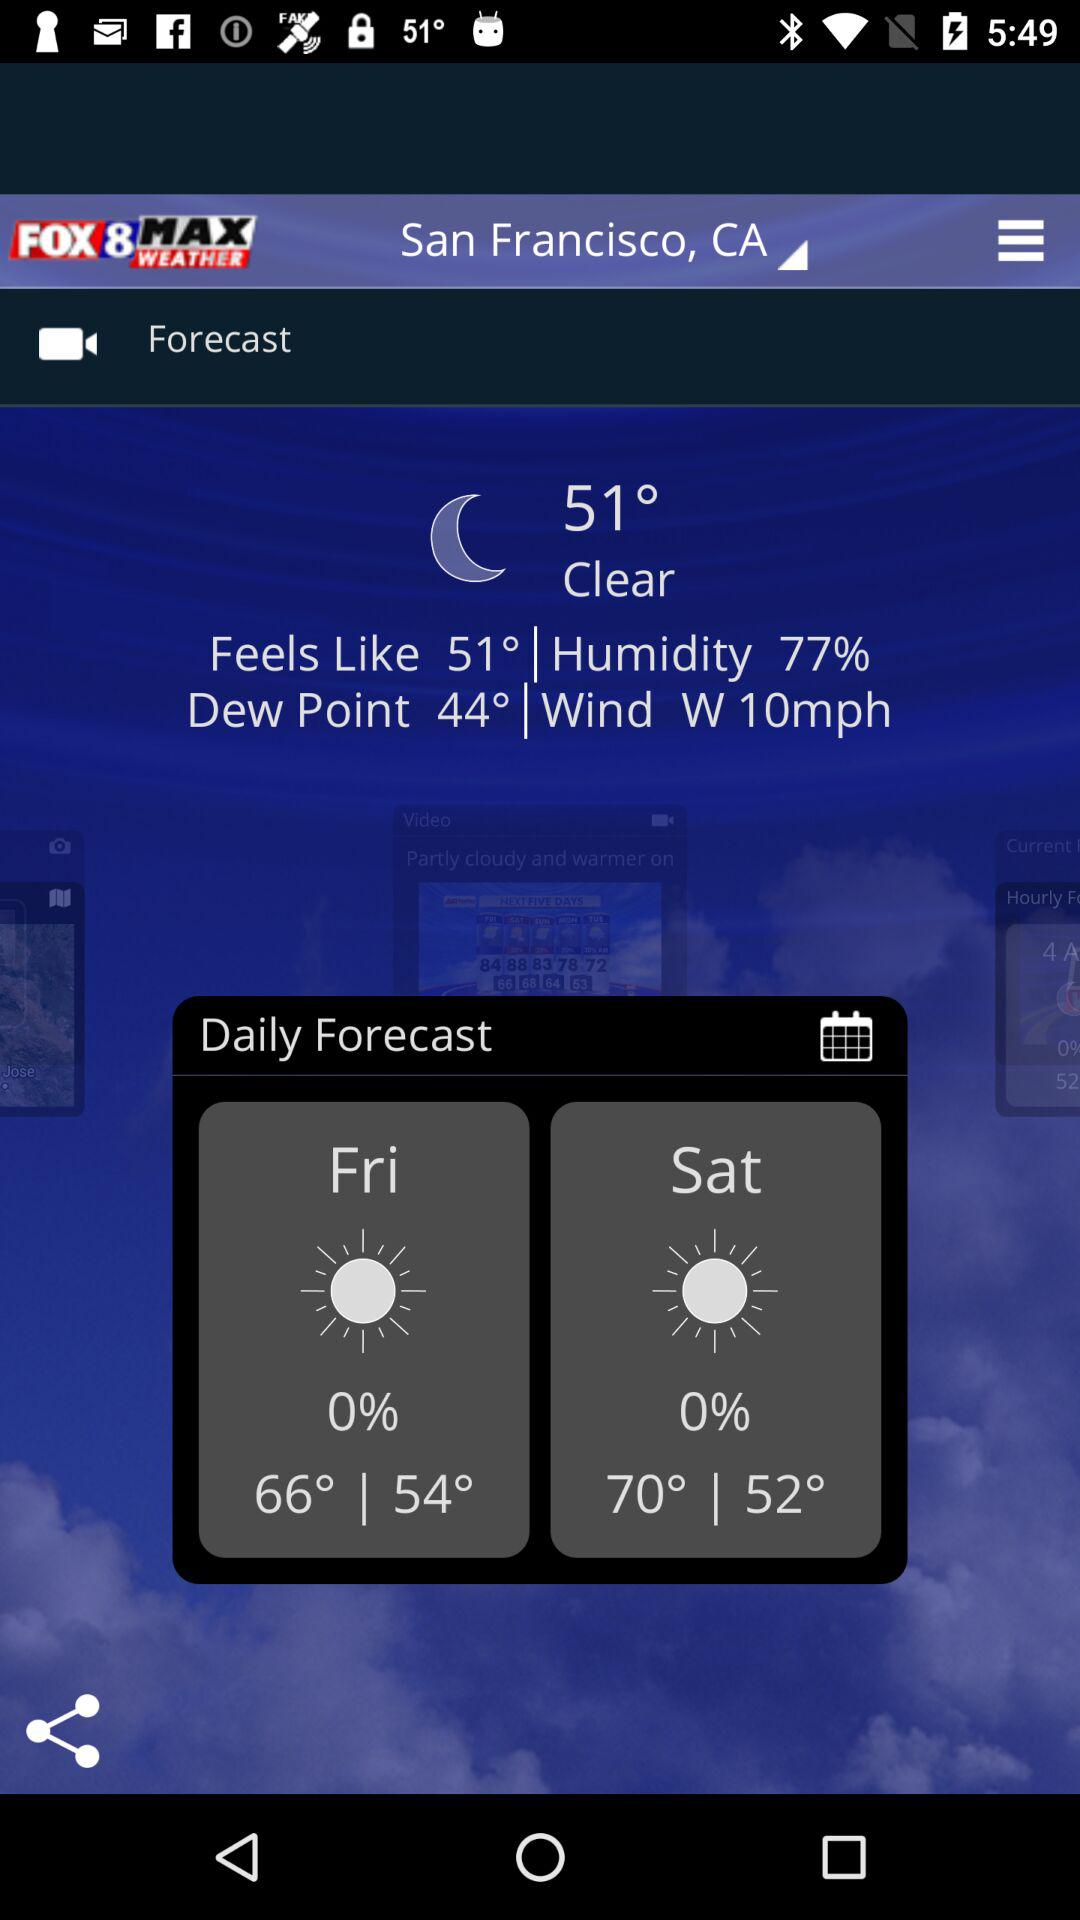What is the temperature on Friday? The temperature on Friday ranges from 54° to 66°. 